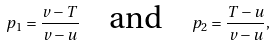<formula> <loc_0><loc_0><loc_500><loc_500>p _ { 1 } = \frac { v - T } { v - u } \quad \text {and} \quad p _ { 2 } = \frac { T - u } { v - u } ,</formula> 